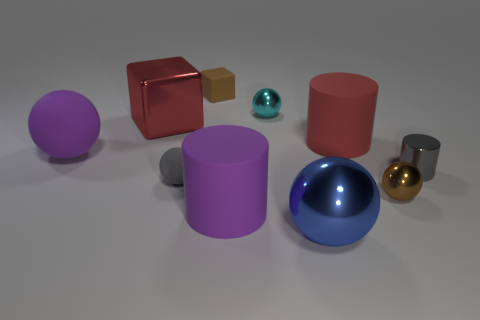Subtract all large purple rubber balls. How many balls are left? 4 Subtract 3 balls. How many balls are left? 2 Subtract all cylinders. How many objects are left? 7 Subtract all purple spheres. How many spheres are left? 4 Subtract all red cylinders. Subtract all red balls. How many cylinders are left? 2 Subtract all shiny spheres. Subtract all big rubber objects. How many objects are left? 4 Add 6 cyan shiny balls. How many cyan shiny balls are left? 7 Add 2 blocks. How many blocks exist? 4 Subtract 0 gray blocks. How many objects are left? 10 